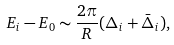<formula> <loc_0><loc_0><loc_500><loc_500>E _ { i } - E _ { 0 } \sim \frac { 2 \pi } { R } ( \Delta _ { i } + \bar { \Delta } _ { i } ) ,</formula> 